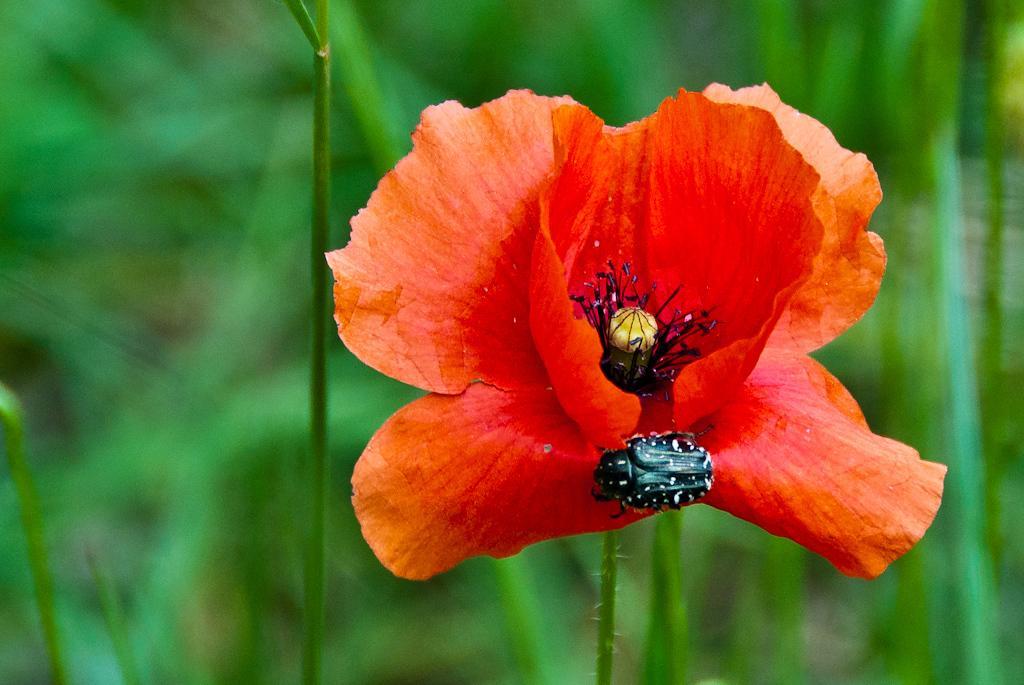Please provide a concise description of this image. In this picture I can observe red color flower. There is a black color insect. In the background there are plants. 